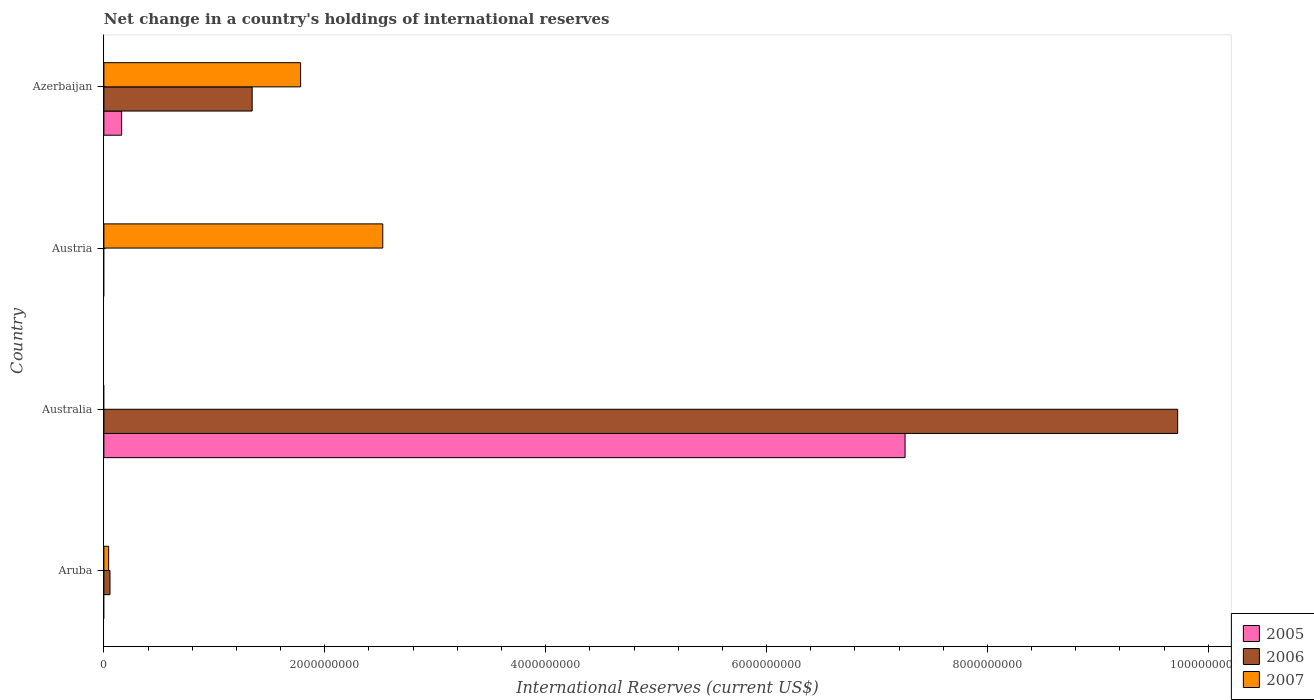How many different coloured bars are there?
Offer a terse response. 3. Are the number of bars per tick equal to the number of legend labels?
Ensure brevity in your answer.  No. How many bars are there on the 3rd tick from the bottom?
Your answer should be very brief. 1. What is the label of the 1st group of bars from the top?
Provide a succinct answer. Azerbaijan. In how many cases, is the number of bars for a given country not equal to the number of legend labels?
Offer a very short reply. 3. Across all countries, what is the maximum international reserves in 2006?
Give a very brief answer. 9.72e+09. What is the total international reserves in 2006 in the graph?
Your response must be concise. 1.11e+1. What is the difference between the international reserves in 2007 in Aruba and that in Azerbaijan?
Keep it short and to the point. -1.74e+09. What is the difference between the international reserves in 2006 in Azerbaijan and the international reserves in 2007 in Austria?
Offer a very short reply. -1.18e+09. What is the average international reserves in 2006 per country?
Your response must be concise. 2.78e+09. What is the difference between the international reserves in 2006 and international reserves in 2005 in Azerbaijan?
Give a very brief answer. 1.18e+09. In how many countries, is the international reserves in 2006 greater than 5600000000 US$?
Offer a very short reply. 1. What is the ratio of the international reserves in 2007 in Aruba to that in Azerbaijan?
Your answer should be very brief. 0.02. Is the international reserves in 2007 in Aruba less than that in Azerbaijan?
Give a very brief answer. Yes. What is the difference between the highest and the second highest international reserves in 2007?
Your answer should be compact. 7.44e+08. What is the difference between the highest and the lowest international reserves in 2007?
Your answer should be compact. 2.53e+09. In how many countries, is the international reserves in 2005 greater than the average international reserves in 2005 taken over all countries?
Provide a short and direct response. 1. Is the sum of the international reserves in 2006 in Australia and Azerbaijan greater than the maximum international reserves in 2005 across all countries?
Provide a short and direct response. Yes. How many bars are there?
Provide a succinct answer. 8. What is the difference between two consecutive major ticks on the X-axis?
Your response must be concise. 2.00e+09. Does the graph contain any zero values?
Offer a terse response. Yes. Does the graph contain grids?
Provide a short and direct response. No. How are the legend labels stacked?
Offer a very short reply. Vertical. What is the title of the graph?
Your answer should be compact. Net change in a country's holdings of international reserves. Does "1977" appear as one of the legend labels in the graph?
Provide a short and direct response. No. What is the label or title of the X-axis?
Ensure brevity in your answer.  International Reserves (current US$). What is the label or title of the Y-axis?
Make the answer very short. Country. What is the International Reserves (current US$) in 2006 in Aruba?
Provide a succinct answer. 5.51e+07. What is the International Reserves (current US$) of 2007 in Aruba?
Offer a terse response. 4.32e+07. What is the International Reserves (current US$) of 2005 in Australia?
Provide a short and direct response. 7.25e+09. What is the International Reserves (current US$) in 2006 in Australia?
Your response must be concise. 9.72e+09. What is the International Reserves (current US$) of 2007 in Australia?
Make the answer very short. 0. What is the International Reserves (current US$) in 2005 in Austria?
Your response must be concise. 0. What is the International Reserves (current US$) of 2007 in Austria?
Your response must be concise. 2.53e+09. What is the International Reserves (current US$) of 2005 in Azerbaijan?
Keep it short and to the point. 1.61e+08. What is the International Reserves (current US$) of 2006 in Azerbaijan?
Your answer should be very brief. 1.34e+09. What is the International Reserves (current US$) in 2007 in Azerbaijan?
Your answer should be very brief. 1.78e+09. Across all countries, what is the maximum International Reserves (current US$) of 2005?
Provide a short and direct response. 7.25e+09. Across all countries, what is the maximum International Reserves (current US$) of 2006?
Give a very brief answer. 9.72e+09. Across all countries, what is the maximum International Reserves (current US$) of 2007?
Your answer should be compact. 2.53e+09. Across all countries, what is the minimum International Reserves (current US$) of 2006?
Your response must be concise. 0. What is the total International Reserves (current US$) in 2005 in the graph?
Give a very brief answer. 7.41e+09. What is the total International Reserves (current US$) of 2006 in the graph?
Ensure brevity in your answer.  1.11e+1. What is the total International Reserves (current US$) of 2007 in the graph?
Provide a succinct answer. 4.35e+09. What is the difference between the International Reserves (current US$) of 2006 in Aruba and that in Australia?
Offer a very short reply. -9.67e+09. What is the difference between the International Reserves (current US$) in 2007 in Aruba and that in Austria?
Provide a short and direct response. -2.48e+09. What is the difference between the International Reserves (current US$) of 2006 in Aruba and that in Azerbaijan?
Offer a terse response. -1.29e+09. What is the difference between the International Reserves (current US$) in 2007 in Aruba and that in Azerbaijan?
Your answer should be very brief. -1.74e+09. What is the difference between the International Reserves (current US$) of 2005 in Australia and that in Azerbaijan?
Make the answer very short. 7.09e+09. What is the difference between the International Reserves (current US$) of 2006 in Australia and that in Azerbaijan?
Offer a terse response. 8.38e+09. What is the difference between the International Reserves (current US$) in 2007 in Austria and that in Azerbaijan?
Your answer should be compact. 7.44e+08. What is the difference between the International Reserves (current US$) in 2006 in Aruba and the International Reserves (current US$) in 2007 in Austria?
Provide a succinct answer. -2.47e+09. What is the difference between the International Reserves (current US$) in 2006 in Aruba and the International Reserves (current US$) in 2007 in Azerbaijan?
Provide a short and direct response. -1.73e+09. What is the difference between the International Reserves (current US$) of 2005 in Australia and the International Reserves (current US$) of 2007 in Austria?
Make the answer very short. 4.73e+09. What is the difference between the International Reserves (current US$) of 2006 in Australia and the International Reserves (current US$) of 2007 in Austria?
Offer a terse response. 7.20e+09. What is the difference between the International Reserves (current US$) in 2005 in Australia and the International Reserves (current US$) in 2006 in Azerbaijan?
Make the answer very short. 5.91e+09. What is the difference between the International Reserves (current US$) of 2005 in Australia and the International Reserves (current US$) of 2007 in Azerbaijan?
Keep it short and to the point. 5.47e+09. What is the difference between the International Reserves (current US$) of 2006 in Australia and the International Reserves (current US$) of 2007 in Azerbaijan?
Provide a succinct answer. 7.94e+09. What is the average International Reserves (current US$) of 2005 per country?
Your answer should be compact. 1.85e+09. What is the average International Reserves (current US$) of 2006 per country?
Offer a very short reply. 2.78e+09. What is the average International Reserves (current US$) of 2007 per country?
Keep it short and to the point. 1.09e+09. What is the difference between the International Reserves (current US$) of 2006 and International Reserves (current US$) of 2007 in Aruba?
Give a very brief answer. 1.20e+07. What is the difference between the International Reserves (current US$) in 2005 and International Reserves (current US$) in 2006 in Australia?
Ensure brevity in your answer.  -2.47e+09. What is the difference between the International Reserves (current US$) of 2005 and International Reserves (current US$) of 2006 in Azerbaijan?
Offer a very short reply. -1.18e+09. What is the difference between the International Reserves (current US$) of 2005 and International Reserves (current US$) of 2007 in Azerbaijan?
Keep it short and to the point. -1.62e+09. What is the difference between the International Reserves (current US$) of 2006 and International Reserves (current US$) of 2007 in Azerbaijan?
Offer a terse response. -4.39e+08. What is the ratio of the International Reserves (current US$) of 2006 in Aruba to that in Australia?
Ensure brevity in your answer.  0.01. What is the ratio of the International Reserves (current US$) of 2007 in Aruba to that in Austria?
Ensure brevity in your answer.  0.02. What is the ratio of the International Reserves (current US$) of 2006 in Aruba to that in Azerbaijan?
Give a very brief answer. 0.04. What is the ratio of the International Reserves (current US$) of 2007 in Aruba to that in Azerbaijan?
Offer a terse response. 0.02. What is the ratio of the International Reserves (current US$) in 2005 in Australia to that in Azerbaijan?
Your answer should be very brief. 45.2. What is the ratio of the International Reserves (current US$) of 2006 in Australia to that in Azerbaijan?
Keep it short and to the point. 7.24. What is the ratio of the International Reserves (current US$) of 2007 in Austria to that in Azerbaijan?
Your response must be concise. 1.42. What is the difference between the highest and the second highest International Reserves (current US$) in 2006?
Your answer should be compact. 8.38e+09. What is the difference between the highest and the second highest International Reserves (current US$) of 2007?
Provide a succinct answer. 7.44e+08. What is the difference between the highest and the lowest International Reserves (current US$) in 2005?
Make the answer very short. 7.25e+09. What is the difference between the highest and the lowest International Reserves (current US$) of 2006?
Provide a short and direct response. 9.72e+09. What is the difference between the highest and the lowest International Reserves (current US$) in 2007?
Offer a terse response. 2.53e+09. 